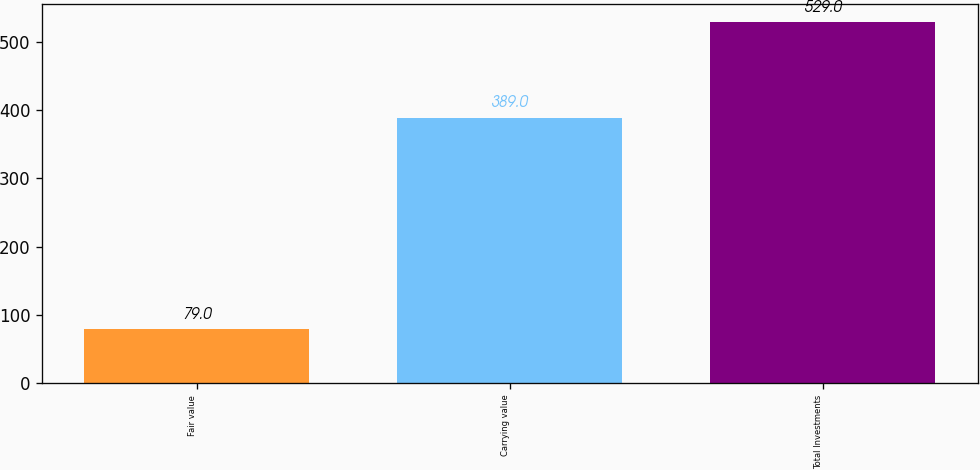Convert chart. <chart><loc_0><loc_0><loc_500><loc_500><bar_chart><fcel>Fair value<fcel>Carrying value<fcel>Total Investments<nl><fcel>79<fcel>389<fcel>529<nl></chart> 